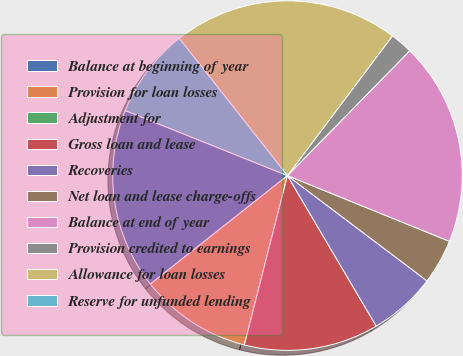Convert chart to OTSL. <chart><loc_0><loc_0><loc_500><loc_500><pie_chart><fcel>Balance at beginning of year<fcel>Provision for loan losses<fcel>Adjustment for<fcel>Gross loan and lease<fcel>Recoveries<fcel>Net loan and lease charge-offs<fcel>Balance at end of year<fcel>Provision credited to earnings<fcel>Allowance for loan losses<fcel>Reserve for unfunded lending<nl><fcel>16.72%<fcel>10.38%<fcel>0.0%<fcel>12.45%<fcel>6.23%<fcel>4.15%<fcel>18.8%<fcel>2.08%<fcel>20.88%<fcel>8.3%<nl></chart> 